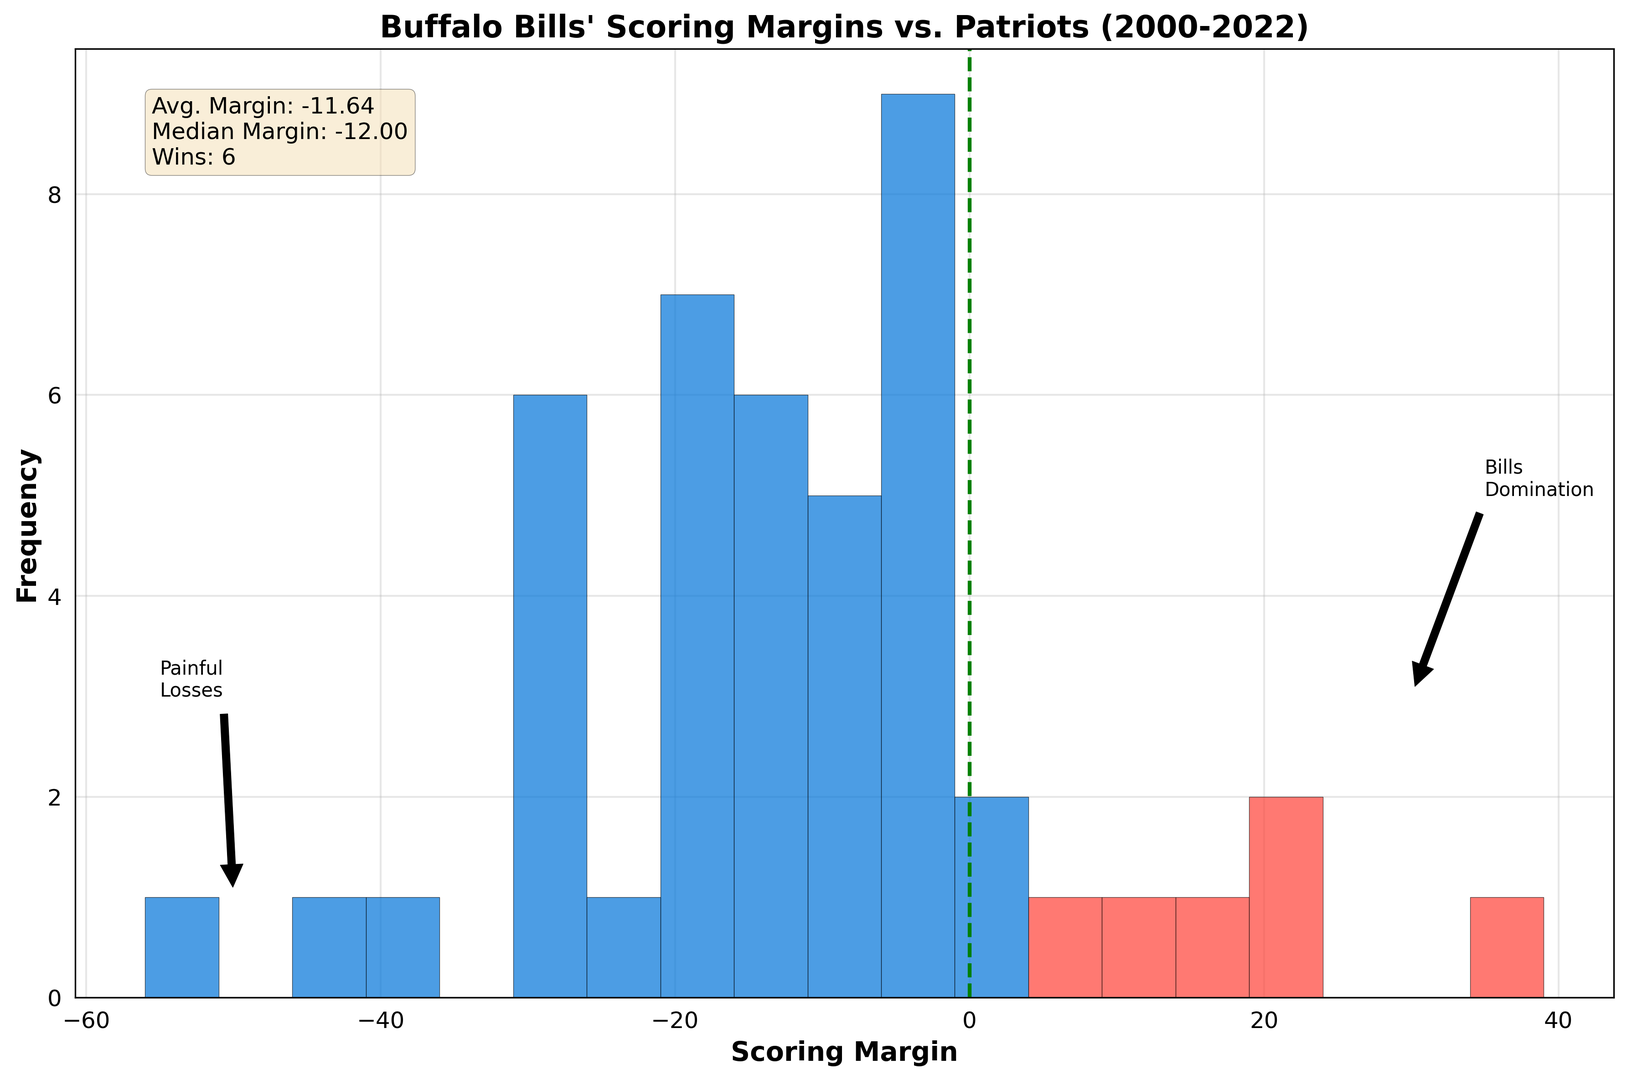what is the average scoring margin for the Buffalo Bills against the Patriots since 2000? The average scoring margin is shown in the text box at the top-right of the plot as "Avg. Margin".
Answer: -11.43 How many games did the Bills win against the Patriots since 2000? The number of wins is provided in the text box in the plot indicated by "Wins".
Answer: 6 What is the median scoring margin? The median scoring margin is indicated in the text box at the top-right of the plot as "Median Margin".
Answer: -11.50 What does the red color represent in the histogram? According to the visual attributes, the red color represents the games where the Bills had a positive scoring margin.
Answer: Wins for the Bills Which visual annotation highlights games where the Bills dominated? The annotation with the label "Bills Domination" indicates games where the Bills were dominant.
Answer: Bills Domination What can you infer from the green dashed line at x=0? The green dashed line at x=0 represents a scoring margin of zero, indicating games where the scores were tied or there was no scoring margin. It's used as a visual reference point.
Answer: Reference point for ties and no margin How does the number of games with positive scoring margins compare to those with negative scoring margins? The histogram visually shows that there are fewer red bars (positive margins) compared to blue bars (negative margins), indicating that the Bills had more games with negative scoring margins.
Answer: More games with negative scoring margins What scoring margin range has the highest frequency in the histogram? By examining the height of the bars, the range with the highest frequency is between -10 and -5.
Answer: -10 to -5 Why is there an annotation called "Painful Losses" and where is it located? The annotation is likely highlighting particularly significant losses; it is located near the left side of the histogram around the -50 range.
Answer: Significant losses around -50 range 